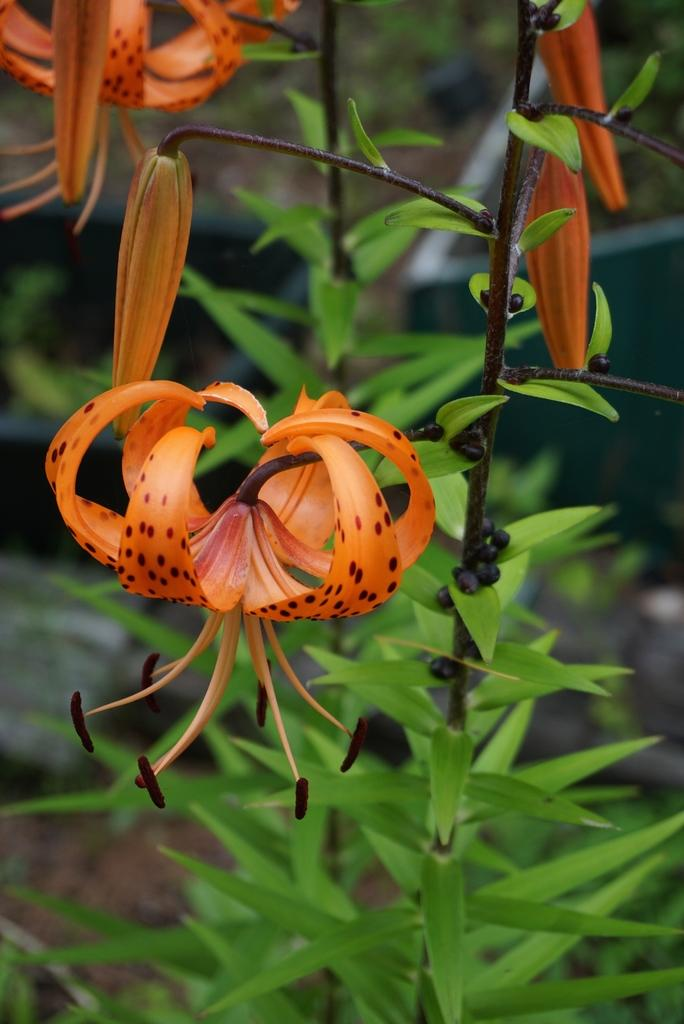What type of living organisms can be seen in the image? Plants can be seen in the image. What specific feature of the plants is visible? The plants have flowers. What color are the flowers? The flowers are orange in color. What type of collar can be seen on the scale in the image? There is no collar or scale present in the image; it features plants with orange flowers. 